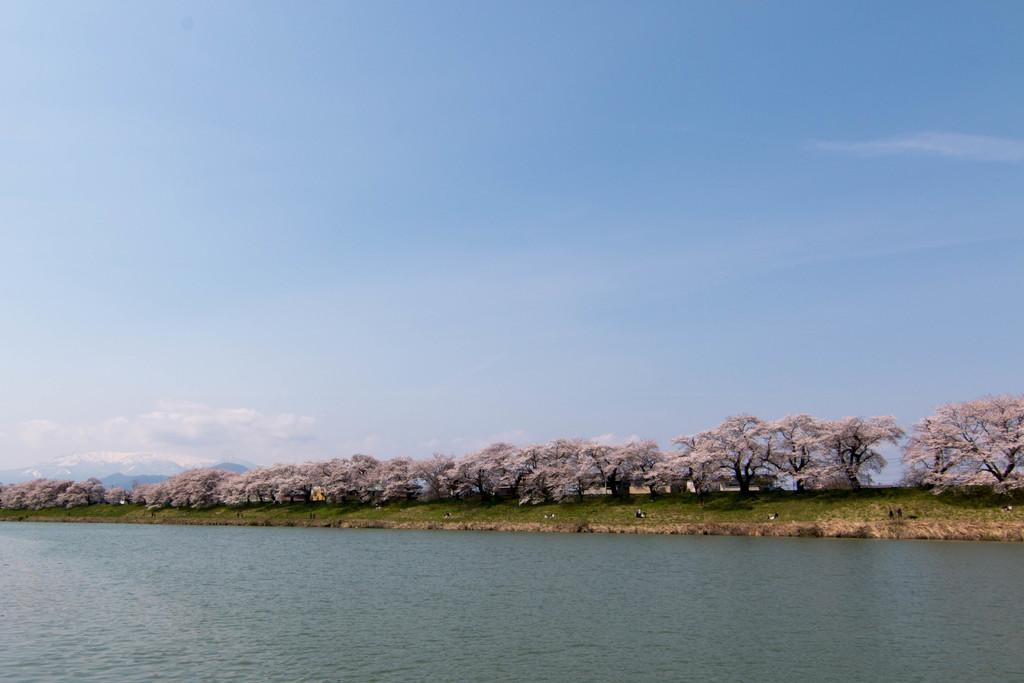What natural feature is the main subject of the image? There is water of a river in the image. What type of vegetation can be seen in the background? There is grass in the background of the image. What other natural elements are present in the image? There are trees on the ground in the image. What is the color of the sky in the image? The sky is blue in the image. Are there any weather elements visible in the sky? Yes, there are clouds in the sky. What type of paper is being used to protect people from the rain in the image? There is no paper or rain present in the image; it features a river, grass, trees, and a blue sky with clouds. 